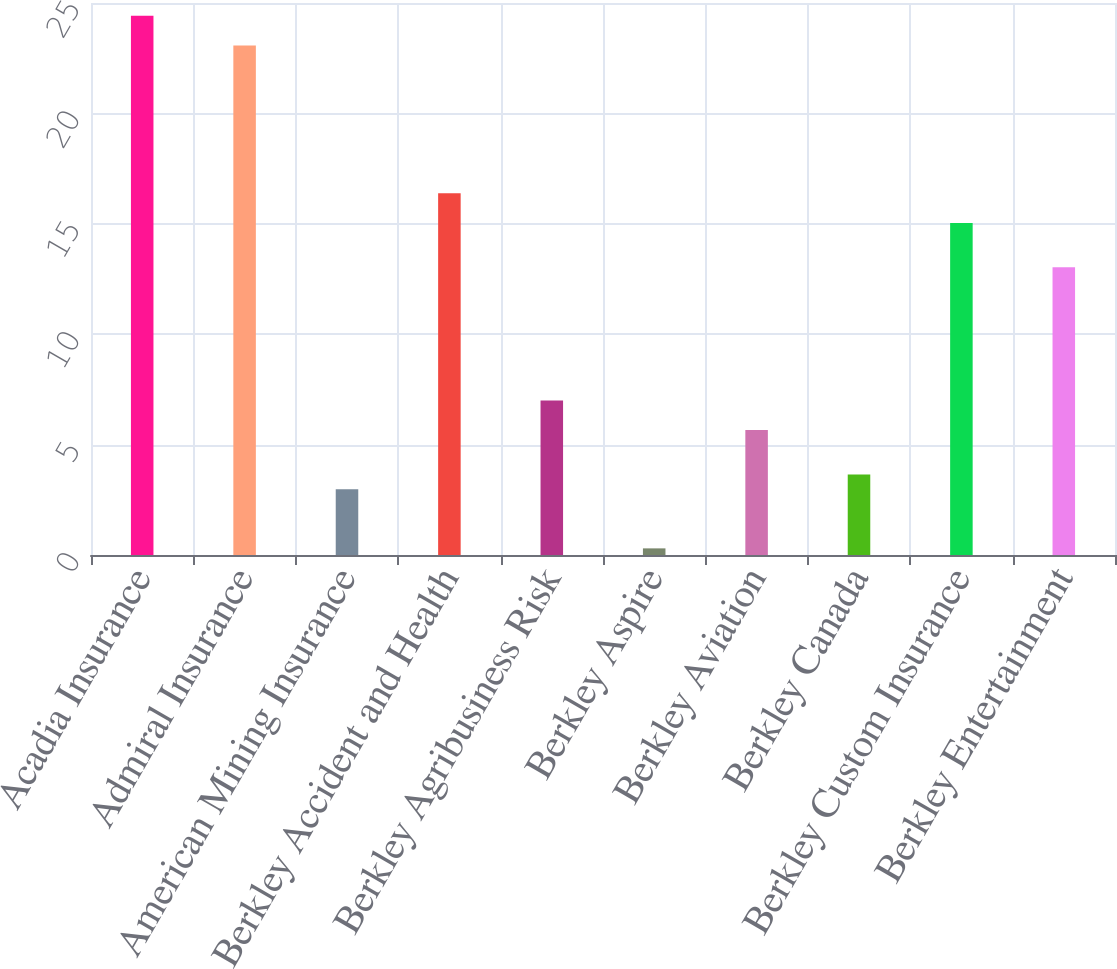Convert chart. <chart><loc_0><loc_0><loc_500><loc_500><bar_chart><fcel>Acadia Insurance<fcel>Admiral Insurance<fcel>American Mining Insurance<fcel>Berkley Accident and Health<fcel>Berkley Agribusiness Risk<fcel>Berkley Aspire<fcel>Berkley Aviation<fcel>Berkley Canada<fcel>Berkley Custom Insurance<fcel>Berkley Entertainment<nl><fcel>24.42<fcel>23.08<fcel>2.98<fcel>16.38<fcel>7<fcel>0.3<fcel>5.66<fcel>3.65<fcel>15.04<fcel>13.03<nl></chart> 